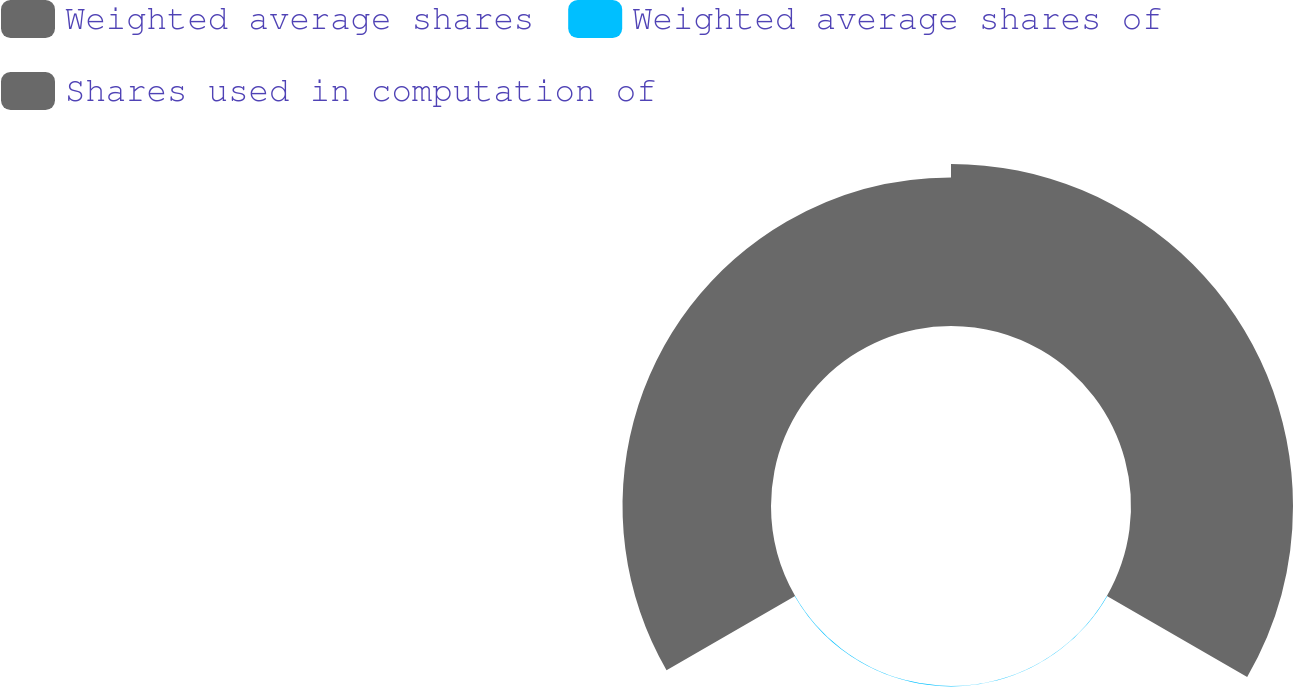Convert chart to OTSL. <chart><loc_0><loc_0><loc_500><loc_500><pie_chart><fcel>Weighted average shares<fcel>Weighted average shares of<fcel>Shares used in computation of<nl><fcel>52.11%<fcel>0.13%<fcel>47.76%<nl></chart> 